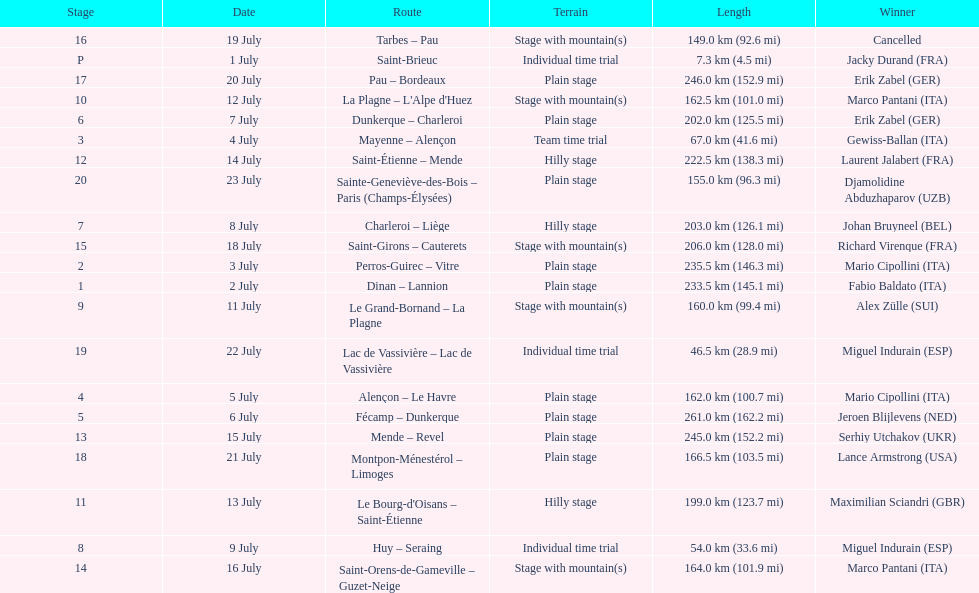How much longer is the 20th tour de france stage than the 19th? 108.5 km. 